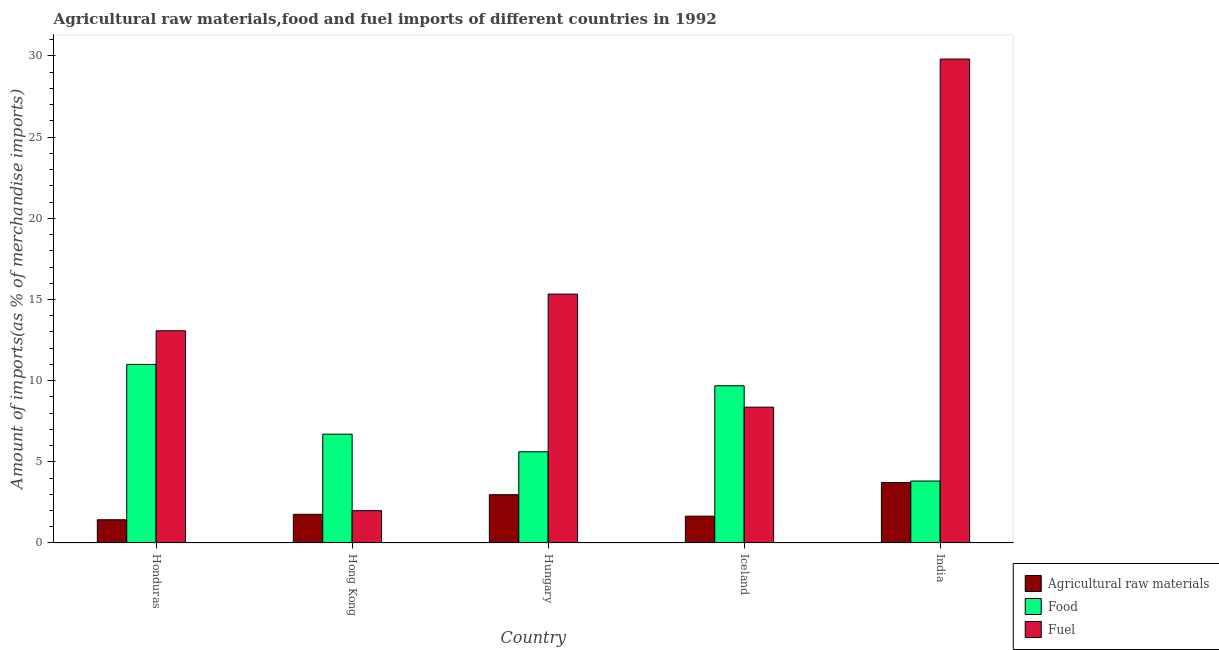Are the number of bars per tick equal to the number of legend labels?
Provide a succinct answer. Yes. How many bars are there on the 4th tick from the left?
Your answer should be very brief. 3. How many bars are there on the 1st tick from the right?
Offer a very short reply. 3. What is the label of the 5th group of bars from the left?
Provide a short and direct response. India. What is the percentage of raw materials imports in Hong Kong?
Keep it short and to the point. 1.77. Across all countries, what is the maximum percentage of fuel imports?
Your answer should be compact. 29.81. Across all countries, what is the minimum percentage of raw materials imports?
Your response must be concise. 1.43. What is the total percentage of food imports in the graph?
Offer a very short reply. 36.82. What is the difference between the percentage of raw materials imports in Hungary and that in Iceland?
Make the answer very short. 1.32. What is the difference between the percentage of food imports in Hungary and the percentage of raw materials imports in India?
Provide a succinct answer. 1.89. What is the average percentage of raw materials imports per country?
Give a very brief answer. 2.31. What is the difference between the percentage of fuel imports and percentage of raw materials imports in Iceland?
Give a very brief answer. 6.71. In how many countries, is the percentage of fuel imports greater than 29 %?
Offer a terse response. 1. What is the ratio of the percentage of raw materials imports in Honduras to that in Hong Kong?
Offer a very short reply. 0.81. Is the percentage of food imports in Hong Kong less than that in Hungary?
Ensure brevity in your answer.  No. What is the difference between the highest and the second highest percentage of food imports?
Offer a very short reply. 1.31. What is the difference between the highest and the lowest percentage of food imports?
Offer a terse response. 7.18. In how many countries, is the percentage of raw materials imports greater than the average percentage of raw materials imports taken over all countries?
Your response must be concise. 2. What does the 2nd bar from the left in Honduras represents?
Provide a short and direct response. Food. What does the 3rd bar from the right in Hong Kong represents?
Your answer should be very brief. Agricultural raw materials. How many bars are there?
Provide a succinct answer. 15. Are all the bars in the graph horizontal?
Your response must be concise. No. What is the difference between two consecutive major ticks on the Y-axis?
Keep it short and to the point. 5. Are the values on the major ticks of Y-axis written in scientific E-notation?
Make the answer very short. No. How are the legend labels stacked?
Your answer should be very brief. Vertical. What is the title of the graph?
Make the answer very short. Agricultural raw materials,food and fuel imports of different countries in 1992. What is the label or title of the Y-axis?
Provide a short and direct response. Amount of imports(as % of merchandise imports). What is the Amount of imports(as % of merchandise imports) of Agricultural raw materials in Honduras?
Offer a very short reply. 1.43. What is the Amount of imports(as % of merchandise imports) of Food in Honduras?
Your answer should be very brief. 11. What is the Amount of imports(as % of merchandise imports) of Fuel in Honduras?
Your answer should be compact. 13.07. What is the Amount of imports(as % of merchandise imports) of Agricultural raw materials in Hong Kong?
Ensure brevity in your answer.  1.77. What is the Amount of imports(as % of merchandise imports) of Food in Hong Kong?
Make the answer very short. 6.7. What is the Amount of imports(as % of merchandise imports) of Fuel in Hong Kong?
Keep it short and to the point. 1.99. What is the Amount of imports(as % of merchandise imports) in Agricultural raw materials in Hungary?
Keep it short and to the point. 2.97. What is the Amount of imports(as % of merchandise imports) in Food in Hungary?
Offer a very short reply. 5.62. What is the Amount of imports(as % of merchandise imports) in Fuel in Hungary?
Your response must be concise. 15.33. What is the Amount of imports(as % of merchandise imports) of Agricultural raw materials in Iceland?
Give a very brief answer. 1.65. What is the Amount of imports(as % of merchandise imports) of Food in Iceland?
Your answer should be very brief. 9.68. What is the Amount of imports(as % of merchandise imports) of Fuel in Iceland?
Offer a terse response. 8.37. What is the Amount of imports(as % of merchandise imports) in Agricultural raw materials in India?
Ensure brevity in your answer.  3.72. What is the Amount of imports(as % of merchandise imports) of Food in India?
Make the answer very short. 3.82. What is the Amount of imports(as % of merchandise imports) of Fuel in India?
Your answer should be very brief. 29.81. Across all countries, what is the maximum Amount of imports(as % of merchandise imports) in Agricultural raw materials?
Keep it short and to the point. 3.72. Across all countries, what is the maximum Amount of imports(as % of merchandise imports) of Food?
Offer a very short reply. 11. Across all countries, what is the maximum Amount of imports(as % of merchandise imports) of Fuel?
Ensure brevity in your answer.  29.81. Across all countries, what is the minimum Amount of imports(as % of merchandise imports) of Agricultural raw materials?
Your answer should be very brief. 1.43. Across all countries, what is the minimum Amount of imports(as % of merchandise imports) in Food?
Your answer should be very brief. 3.82. Across all countries, what is the minimum Amount of imports(as % of merchandise imports) of Fuel?
Keep it short and to the point. 1.99. What is the total Amount of imports(as % of merchandise imports) in Agricultural raw materials in the graph?
Ensure brevity in your answer.  11.55. What is the total Amount of imports(as % of merchandise imports) of Food in the graph?
Give a very brief answer. 36.82. What is the total Amount of imports(as % of merchandise imports) in Fuel in the graph?
Your answer should be very brief. 68.57. What is the difference between the Amount of imports(as % of merchandise imports) in Agricultural raw materials in Honduras and that in Hong Kong?
Provide a short and direct response. -0.34. What is the difference between the Amount of imports(as % of merchandise imports) in Food in Honduras and that in Hong Kong?
Ensure brevity in your answer.  4.3. What is the difference between the Amount of imports(as % of merchandise imports) of Fuel in Honduras and that in Hong Kong?
Keep it short and to the point. 11.08. What is the difference between the Amount of imports(as % of merchandise imports) in Agricultural raw materials in Honduras and that in Hungary?
Offer a terse response. -1.54. What is the difference between the Amount of imports(as % of merchandise imports) of Food in Honduras and that in Hungary?
Your answer should be very brief. 5.38. What is the difference between the Amount of imports(as % of merchandise imports) of Fuel in Honduras and that in Hungary?
Offer a terse response. -2.26. What is the difference between the Amount of imports(as % of merchandise imports) in Agricultural raw materials in Honduras and that in Iceland?
Make the answer very short. -0.22. What is the difference between the Amount of imports(as % of merchandise imports) of Food in Honduras and that in Iceland?
Offer a very short reply. 1.31. What is the difference between the Amount of imports(as % of merchandise imports) of Fuel in Honduras and that in Iceland?
Provide a short and direct response. 4.71. What is the difference between the Amount of imports(as % of merchandise imports) of Agricultural raw materials in Honduras and that in India?
Your answer should be very brief. -2.29. What is the difference between the Amount of imports(as % of merchandise imports) in Food in Honduras and that in India?
Offer a terse response. 7.18. What is the difference between the Amount of imports(as % of merchandise imports) in Fuel in Honduras and that in India?
Ensure brevity in your answer.  -16.74. What is the difference between the Amount of imports(as % of merchandise imports) of Agricultural raw materials in Hong Kong and that in Hungary?
Give a very brief answer. -1.21. What is the difference between the Amount of imports(as % of merchandise imports) in Food in Hong Kong and that in Hungary?
Make the answer very short. 1.08. What is the difference between the Amount of imports(as % of merchandise imports) in Fuel in Hong Kong and that in Hungary?
Offer a terse response. -13.34. What is the difference between the Amount of imports(as % of merchandise imports) of Agricultural raw materials in Hong Kong and that in Iceland?
Your answer should be compact. 0.11. What is the difference between the Amount of imports(as % of merchandise imports) of Food in Hong Kong and that in Iceland?
Make the answer very short. -2.98. What is the difference between the Amount of imports(as % of merchandise imports) of Fuel in Hong Kong and that in Iceland?
Provide a succinct answer. -6.37. What is the difference between the Amount of imports(as % of merchandise imports) in Agricultural raw materials in Hong Kong and that in India?
Your response must be concise. -1.96. What is the difference between the Amount of imports(as % of merchandise imports) of Food in Hong Kong and that in India?
Ensure brevity in your answer.  2.89. What is the difference between the Amount of imports(as % of merchandise imports) in Fuel in Hong Kong and that in India?
Your answer should be very brief. -27.82. What is the difference between the Amount of imports(as % of merchandise imports) in Agricultural raw materials in Hungary and that in Iceland?
Give a very brief answer. 1.32. What is the difference between the Amount of imports(as % of merchandise imports) in Food in Hungary and that in Iceland?
Your response must be concise. -4.07. What is the difference between the Amount of imports(as % of merchandise imports) of Fuel in Hungary and that in Iceland?
Your answer should be compact. 6.97. What is the difference between the Amount of imports(as % of merchandise imports) in Agricultural raw materials in Hungary and that in India?
Make the answer very short. -0.75. What is the difference between the Amount of imports(as % of merchandise imports) in Food in Hungary and that in India?
Provide a succinct answer. 1.8. What is the difference between the Amount of imports(as % of merchandise imports) of Fuel in Hungary and that in India?
Keep it short and to the point. -14.48. What is the difference between the Amount of imports(as % of merchandise imports) in Agricultural raw materials in Iceland and that in India?
Provide a short and direct response. -2.07. What is the difference between the Amount of imports(as % of merchandise imports) in Food in Iceland and that in India?
Provide a short and direct response. 5.87. What is the difference between the Amount of imports(as % of merchandise imports) of Fuel in Iceland and that in India?
Your answer should be very brief. -21.44. What is the difference between the Amount of imports(as % of merchandise imports) of Agricultural raw materials in Honduras and the Amount of imports(as % of merchandise imports) of Food in Hong Kong?
Make the answer very short. -5.27. What is the difference between the Amount of imports(as % of merchandise imports) in Agricultural raw materials in Honduras and the Amount of imports(as % of merchandise imports) in Fuel in Hong Kong?
Offer a terse response. -0.56. What is the difference between the Amount of imports(as % of merchandise imports) in Food in Honduras and the Amount of imports(as % of merchandise imports) in Fuel in Hong Kong?
Provide a short and direct response. 9.01. What is the difference between the Amount of imports(as % of merchandise imports) of Agricultural raw materials in Honduras and the Amount of imports(as % of merchandise imports) of Food in Hungary?
Offer a terse response. -4.19. What is the difference between the Amount of imports(as % of merchandise imports) in Agricultural raw materials in Honduras and the Amount of imports(as % of merchandise imports) in Fuel in Hungary?
Ensure brevity in your answer.  -13.9. What is the difference between the Amount of imports(as % of merchandise imports) of Food in Honduras and the Amount of imports(as % of merchandise imports) of Fuel in Hungary?
Offer a terse response. -4.33. What is the difference between the Amount of imports(as % of merchandise imports) of Agricultural raw materials in Honduras and the Amount of imports(as % of merchandise imports) of Food in Iceland?
Offer a terse response. -8.25. What is the difference between the Amount of imports(as % of merchandise imports) in Agricultural raw materials in Honduras and the Amount of imports(as % of merchandise imports) in Fuel in Iceland?
Provide a succinct answer. -6.94. What is the difference between the Amount of imports(as % of merchandise imports) in Food in Honduras and the Amount of imports(as % of merchandise imports) in Fuel in Iceland?
Provide a succinct answer. 2.63. What is the difference between the Amount of imports(as % of merchandise imports) in Agricultural raw materials in Honduras and the Amount of imports(as % of merchandise imports) in Food in India?
Provide a short and direct response. -2.39. What is the difference between the Amount of imports(as % of merchandise imports) in Agricultural raw materials in Honduras and the Amount of imports(as % of merchandise imports) in Fuel in India?
Make the answer very short. -28.38. What is the difference between the Amount of imports(as % of merchandise imports) of Food in Honduras and the Amount of imports(as % of merchandise imports) of Fuel in India?
Your response must be concise. -18.81. What is the difference between the Amount of imports(as % of merchandise imports) of Agricultural raw materials in Hong Kong and the Amount of imports(as % of merchandise imports) of Food in Hungary?
Your answer should be very brief. -3.85. What is the difference between the Amount of imports(as % of merchandise imports) of Agricultural raw materials in Hong Kong and the Amount of imports(as % of merchandise imports) of Fuel in Hungary?
Give a very brief answer. -13.57. What is the difference between the Amount of imports(as % of merchandise imports) in Food in Hong Kong and the Amount of imports(as % of merchandise imports) in Fuel in Hungary?
Make the answer very short. -8.63. What is the difference between the Amount of imports(as % of merchandise imports) in Agricultural raw materials in Hong Kong and the Amount of imports(as % of merchandise imports) in Food in Iceland?
Give a very brief answer. -7.92. What is the difference between the Amount of imports(as % of merchandise imports) of Agricultural raw materials in Hong Kong and the Amount of imports(as % of merchandise imports) of Fuel in Iceland?
Keep it short and to the point. -6.6. What is the difference between the Amount of imports(as % of merchandise imports) of Food in Hong Kong and the Amount of imports(as % of merchandise imports) of Fuel in Iceland?
Keep it short and to the point. -1.66. What is the difference between the Amount of imports(as % of merchandise imports) of Agricultural raw materials in Hong Kong and the Amount of imports(as % of merchandise imports) of Food in India?
Give a very brief answer. -2.05. What is the difference between the Amount of imports(as % of merchandise imports) in Agricultural raw materials in Hong Kong and the Amount of imports(as % of merchandise imports) in Fuel in India?
Offer a very short reply. -28.04. What is the difference between the Amount of imports(as % of merchandise imports) of Food in Hong Kong and the Amount of imports(as % of merchandise imports) of Fuel in India?
Your response must be concise. -23.1. What is the difference between the Amount of imports(as % of merchandise imports) in Agricultural raw materials in Hungary and the Amount of imports(as % of merchandise imports) in Food in Iceland?
Your response must be concise. -6.71. What is the difference between the Amount of imports(as % of merchandise imports) in Agricultural raw materials in Hungary and the Amount of imports(as % of merchandise imports) in Fuel in Iceland?
Ensure brevity in your answer.  -5.39. What is the difference between the Amount of imports(as % of merchandise imports) in Food in Hungary and the Amount of imports(as % of merchandise imports) in Fuel in Iceland?
Make the answer very short. -2.75. What is the difference between the Amount of imports(as % of merchandise imports) of Agricultural raw materials in Hungary and the Amount of imports(as % of merchandise imports) of Food in India?
Provide a short and direct response. -0.84. What is the difference between the Amount of imports(as % of merchandise imports) of Agricultural raw materials in Hungary and the Amount of imports(as % of merchandise imports) of Fuel in India?
Your answer should be very brief. -26.83. What is the difference between the Amount of imports(as % of merchandise imports) in Food in Hungary and the Amount of imports(as % of merchandise imports) in Fuel in India?
Ensure brevity in your answer.  -24.19. What is the difference between the Amount of imports(as % of merchandise imports) of Agricultural raw materials in Iceland and the Amount of imports(as % of merchandise imports) of Food in India?
Keep it short and to the point. -2.16. What is the difference between the Amount of imports(as % of merchandise imports) of Agricultural raw materials in Iceland and the Amount of imports(as % of merchandise imports) of Fuel in India?
Your response must be concise. -28.16. What is the difference between the Amount of imports(as % of merchandise imports) in Food in Iceland and the Amount of imports(as % of merchandise imports) in Fuel in India?
Your answer should be compact. -20.12. What is the average Amount of imports(as % of merchandise imports) in Agricultural raw materials per country?
Make the answer very short. 2.31. What is the average Amount of imports(as % of merchandise imports) in Food per country?
Your answer should be very brief. 7.36. What is the average Amount of imports(as % of merchandise imports) of Fuel per country?
Your answer should be compact. 13.71. What is the difference between the Amount of imports(as % of merchandise imports) of Agricultural raw materials and Amount of imports(as % of merchandise imports) of Food in Honduras?
Your answer should be compact. -9.57. What is the difference between the Amount of imports(as % of merchandise imports) in Agricultural raw materials and Amount of imports(as % of merchandise imports) in Fuel in Honduras?
Offer a terse response. -11.64. What is the difference between the Amount of imports(as % of merchandise imports) in Food and Amount of imports(as % of merchandise imports) in Fuel in Honduras?
Provide a succinct answer. -2.07. What is the difference between the Amount of imports(as % of merchandise imports) of Agricultural raw materials and Amount of imports(as % of merchandise imports) of Food in Hong Kong?
Give a very brief answer. -4.94. What is the difference between the Amount of imports(as % of merchandise imports) in Agricultural raw materials and Amount of imports(as % of merchandise imports) in Fuel in Hong Kong?
Provide a short and direct response. -0.23. What is the difference between the Amount of imports(as % of merchandise imports) in Food and Amount of imports(as % of merchandise imports) in Fuel in Hong Kong?
Give a very brief answer. 4.71. What is the difference between the Amount of imports(as % of merchandise imports) of Agricultural raw materials and Amount of imports(as % of merchandise imports) of Food in Hungary?
Your response must be concise. -2.65. What is the difference between the Amount of imports(as % of merchandise imports) in Agricultural raw materials and Amount of imports(as % of merchandise imports) in Fuel in Hungary?
Provide a short and direct response. -12.36. What is the difference between the Amount of imports(as % of merchandise imports) in Food and Amount of imports(as % of merchandise imports) in Fuel in Hungary?
Offer a terse response. -9.71. What is the difference between the Amount of imports(as % of merchandise imports) of Agricultural raw materials and Amount of imports(as % of merchandise imports) of Food in Iceland?
Your response must be concise. -8.03. What is the difference between the Amount of imports(as % of merchandise imports) of Agricultural raw materials and Amount of imports(as % of merchandise imports) of Fuel in Iceland?
Provide a succinct answer. -6.71. What is the difference between the Amount of imports(as % of merchandise imports) of Food and Amount of imports(as % of merchandise imports) of Fuel in Iceland?
Offer a very short reply. 1.32. What is the difference between the Amount of imports(as % of merchandise imports) in Agricultural raw materials and Amount of imports(as % of merchandise imports) in Food in India?
Provide a short and direct response. -0.09. What is the difference between the Amount of imports(as % of merchandise imports) in Agricultural raw materials and Amount of imports(as % of merchandise imports) in Fuel in India?
Give a very brief answer. -26.08. What is the difference between the Amount of imports(as % of merchandise imports) in Food and Amount of imports(as % of merchandise imports) in Fuel in India?
Give a very brief answer. -25.99. What is the ratio of the Amount of imports(as % of merchandise imports) of Agricultural raw materials in Honduras to that in Hong Kong?
Provide a succinct answer. 0.81. What is the ratio of the Amount of imports(as % of merchandise imports) of Food in Honduras to that in Hong Kong?
Your answer should be very brief. 1.64. What is the ratio of the Amount of imports(as % of merchandise imports) of Fuel in Honduras to that in Hong Kong?
Keep it short and to the point. 6.56. What is the ratio of the Amount of imports(as % of merchandise imports) of Agricultural raw materials in Honduras to that in Hungary?
Keep it short and to the point. 0.48. What is the ratio of the Amount of imports(as % of merchandise imports) of Food in Honduras to that in Hungary?
Ensure brevity in your answer.  1.96. What is the ratio of the Amount of imports(as % of merchandise imports) in Fuel in Honduras to that in Hungary?
Your response must be concise. 0.85. What is the ratio of the Amount of imports(as % of merchandise imports) in Agricultural raw materials in Honduras to that in Iceland?
Make the answer very short. 0.87. What is the ratio of the Amount of imports(as % of merchandise imports) of Food in Honduras to that in Iceland?
Your answer should be very brief. 1.14. What is the ratio of the Amount of imports(as % of merchandise imports) of Fuel in Honduras to that in Iceland?
Offer a very short reply. 1.56. What is the ratio of the Amount of imports(as % of merchandise imports) in Agricultural raw materials in Honduras to that in India?
Ensure brevity in your answer.  0.38. What is the ratio of the Amount of imports(as % of merchandise imports) of Food in Honduras to that in India?
Ensure brevity in your answer.  2.88. What is the ratio of the Amount of imports(as % of merchandise imports) of Fuel in Honduras to that in India?
Make the answer very short. 0.44. What is the ratio of the Amount of imports(as % of merchandise imports) of Agricultural raw materials in Hong Kong to that in Hungary?
Offer a terse response. 0.59. What is the ratio of the Amount of imports(as % of merchandise imports) in Food in Hong Kong to that in Hungary?
Offer a terse response. 1.19. What is the ratio of the Amount of imports(as % of merchandise imports) of Fuel in Hong Kong to that in Hungary?
Offer a very short reply. 0.13. What is the ratio of the Amount of imports(as % of merchandise imports) of Agricultural raw materials in Hong Kong to that in Iceland?
Provide a succinct answer. 1.07. What is the ratio of the Amount of imports(as % of merchandise imports) of Food in Hong Kong to that in Iceland?
Give a very brief answer. 0.69. What is the ratio of the Amount of imports(as % of merchandise imports) of Fuel in Hong Kong to that in Iceland?
Your answer should be very brief. 0.24. What is the ratio of the Amount of imports(as % of merchandise imports) in Agricultural raw materials in Hong Kong to that in India?
Provide a succinct answer. 0.47. What is the ratio of the Amount of imports(as % of merchandise imports) of Food in Hong Kong to that in India?
Provide a short and direct response. 1.76. What is the ratio of the Amount of imports(as % of merchandise imports) of Fuel in Hong Kong to that in India?
Your answer should be compact. 0.07. What is the ratio of the Amount of imports(as % of merchandise imports) of Agricultural raw materials in Hungary to that in Iceland?
Your answer should be compact. 1.8. What is the ratio of the Amount of imports(as % of merchandise imports) in Food in Hungary to that in Iceland?
Your answer should be very brief. 0.58. What is the ratio of the Amount of imports(as % of merchandise imports) of Fuel in Hungary to that in Iceland?
Provide a short and direct response. 1.83. What is the ratio of the Amount of imports(as % of merchandise imports) in Agricultural raw materials in Hungary to that in India?
Provide a succinct answer. 0.8. What is the ratio of the Amount of imports(as % of merchandise imports) in Food in Hungary to that in India?
Keep it short and to the point. 1.47. What is the ratio of the Amount of imports(as % of merchandise imports) of Fuel in Hungary to that in India?
Your answer should be very brief. 0.51. What is the ratio of the Amount of imports(as % of merchandise imports) of Agricultural raw materials in Iceland to that in India?
Ensure brevity in your answer.  0.44. What is the ratio of the Amount of imports(as % of merchandise imports) in Food in Iceland to that in India?
Your response must be concise. 2.54. What is the ratio of the Amount of imports(as % of merchandise imports) in Fuel in Iceland to that in India?
Make the answer very short. 0.28. What is the difference between the highest and the second highest Amount of imports(as % of merchandise imports) in Agricultural raw materials?
Provide a short and direct response. 0.75. What is the difference between the highest and the second highest Amount of imports(as % of merchandise imports) in Food?
Keep it short and to the point. 1.31. What is the difference between the highest and the second highest Amount of imports(as % of merchandise imports) of Fuel?
Offer a terse response. 14.48. What is the difference between the highest and the lowest Amount of imports(as % of merchandise imports) of Agricultural raw materials?
Offer a terse response. 2.29. What is the difference between the highest and the lowest Amount of imports(as % of merchandise imports) of Food?
Make the answer very short. 7.18. What is the difference between the highest and the lowest Amount of imports(as % of merchandise imports) of Fuel?
Your response must be concise. 27.82. 